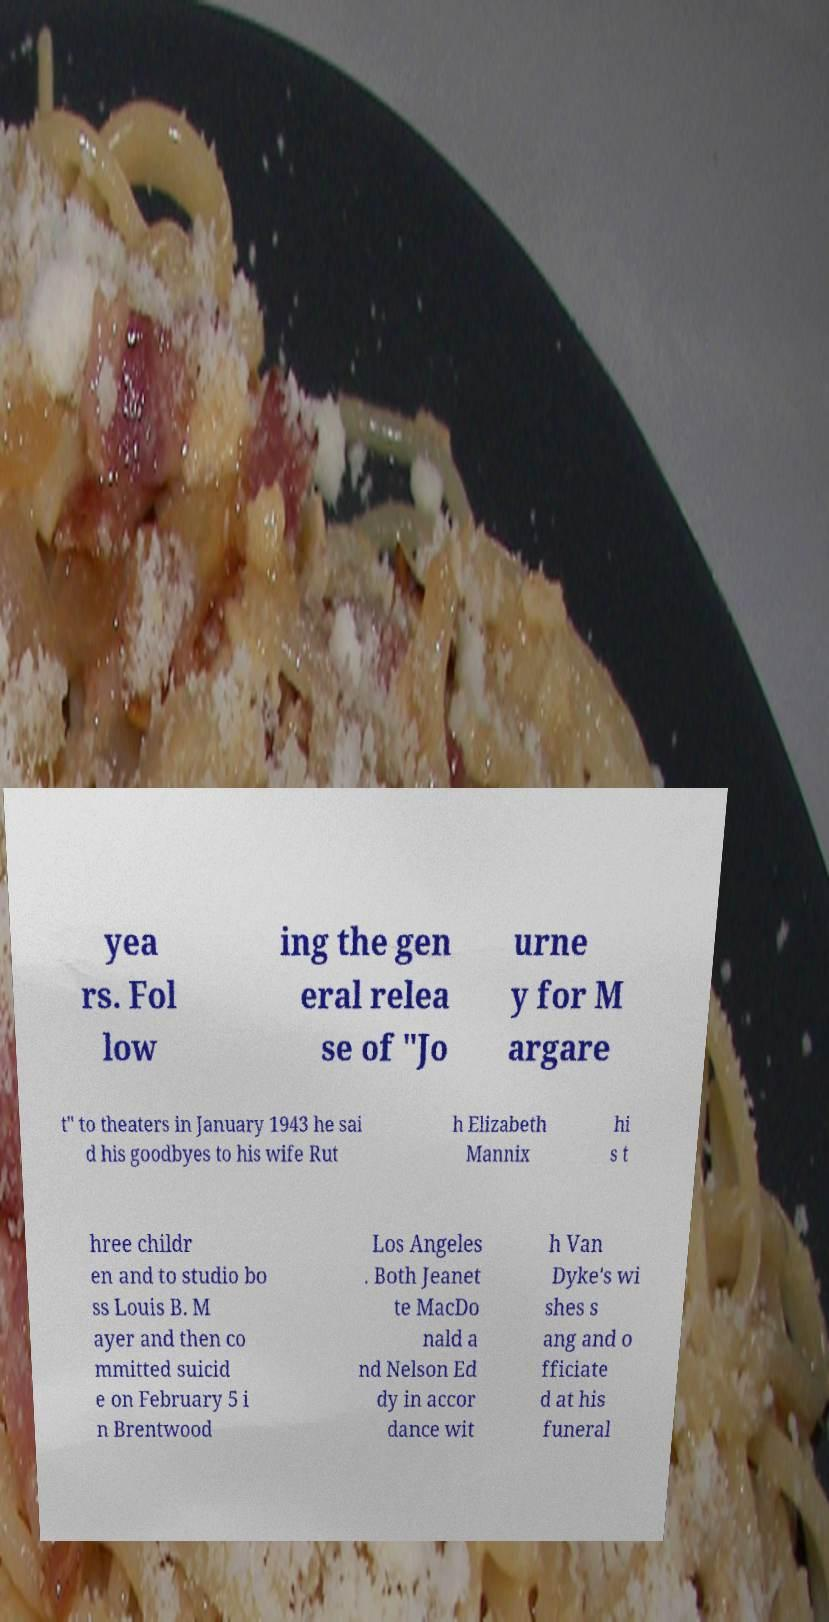Could you extract and type out the text from this image? yea rs. Fol low ing the gen eral relea se of "Jo urne y for M argare t" to theaters in January 1943 he sai d his goodbyes to his wife Rut h Elizabeth Mannix hi s t hree childr en and to studio bo ss Louis B. M ayer and then co mmitted suicid e on February 5 i n Brentwood Los Angeles . Both Jeanet te MacDo nald a nd Nelson Ed dy in accor dance wit h Van Dyke's wi shes s ang and o fficiate d at his funeral 